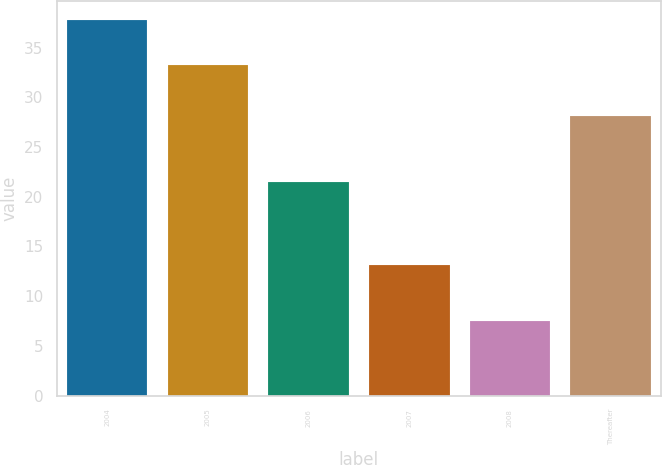Convert chart. <chart><loc_0><loc_0><loc_500><loc_500><bar_chart><fcel>2004<fcel>2005<fcel>2006<fcel>2007<fcel>2008<fcel>Thereafter<nl><fcel>37.8<fcel>33.3<fcel>21.5<fcel>13.1<fcel>7.5<fcel>28.1<nl></chart> 